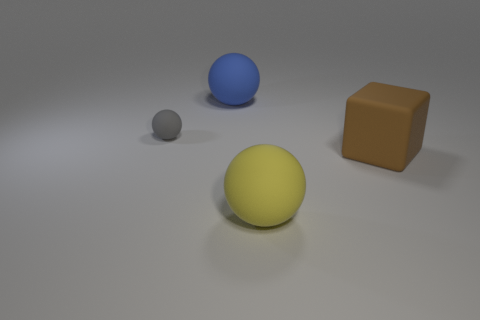What number of metallic objects are either yellow objects or tiny cyan cylinders?
Ensure brevity in your answer.  0. What size is the rubber thing that is to the left of the matte sphere behind the small gray ball?
Keep it short and to the point. Small. The sphere that is both behind the large yellow thing and on the right side of the small gray object is what color?
Offer a very short reply. Blue. What number of large things are gray rubber balls or blue matte spheres?
Provide a short and direct response. 1. Are there any other things that have the same shape as the big brown thing?
Ensure brevity in your answer.  No. Are there any other things that have the same size as the gray rubber sphere?
Ensure brevity in your answer.  No. What is the color of the small sphere that is made of the same material as the large brown thing?
Keep it short and to the point. Gray. There is a big matte ball that is on the right side of the blue rubber ball; what is its color?
Provide a short and direct response. Yellow. Is the number of rubber balls in front of the small matte ball less than the number of matte things that are to the left of the large yellow thing?
Provide a short and direct response. Yes. What number of yellow things are in front of the cube?
Your answer should be very brief. 1. 